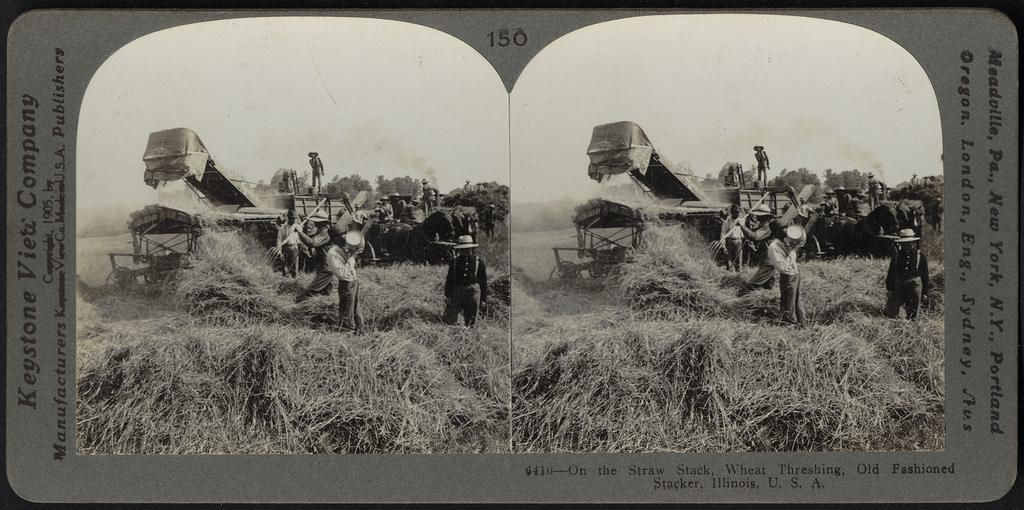<image>
Describe the image concisely. Slide number 150 shows people working on a farm. 